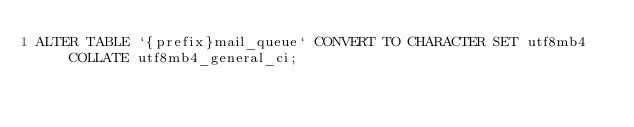Convert code to text. <code><loc_0><loc_0><loc_500><loc_500><_SQL_>ALTER TABLE `{prefix}mail_queue` CONVERT TO CHARACTER SET utf8mb4 COLLATE utf8mb4_general_ci;
</code> 